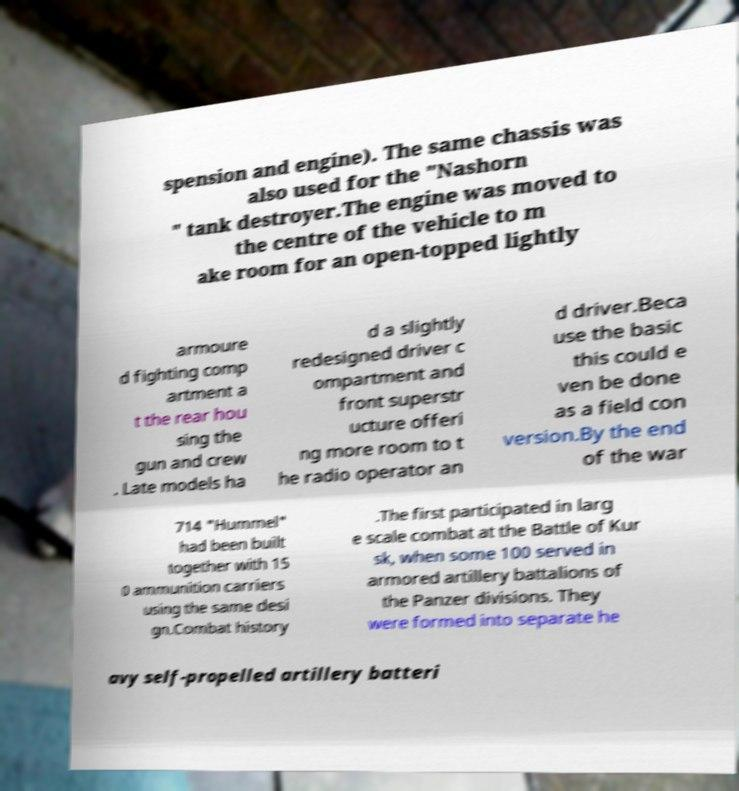I need the written content from this picture converted into text. Can you do that? spension and engine). The same chassis was also used for the "Nashorn " tank destroyer.The engine was moved to the centre of the vehicle to m ake room for an open-topped lightly armoure d fighting comp artment a t the rear hou sing the gun and crew . Late models ha d a slightly redesigned driver c ompartment and front superstr ucture offeri ng more room to t he radio operator an d driver.Beca use the basic this could e ven be done as a field con version.By the end of the war 714 "Hummel" had been built together with 15 0 ammunition carriers using the same desi gn.Combat history .The first participated in larg e scale combat at the Battle of Kur sk, when some 100 served in armored artillery battalions of the Panzer divisions. They were formed into separate he avy self-propelled artillery batteri 